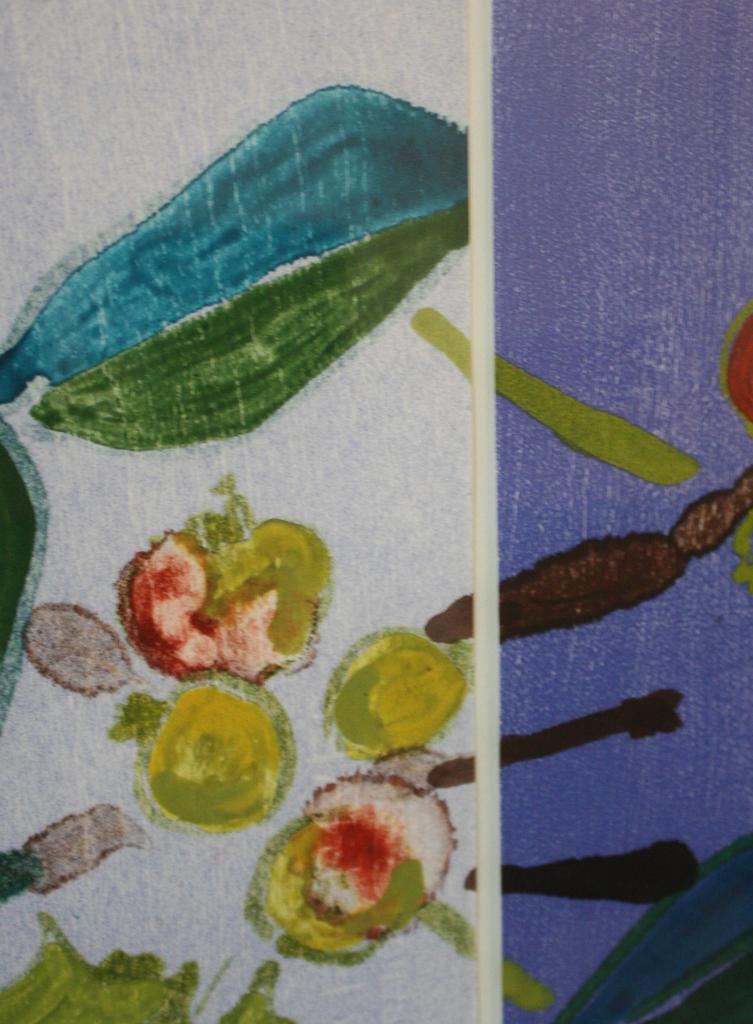What is the main subject of the image? The image contains a colorful drawing. What is being depicted in the drawing? The drawing depicts vegetables. What material is the drawing on? The drawing is on a paper. What type of joke is being told by the vegetables in the drawing? There is no joke being told by the vegetables in the drawing; the drawing simply depicts vegetables. 